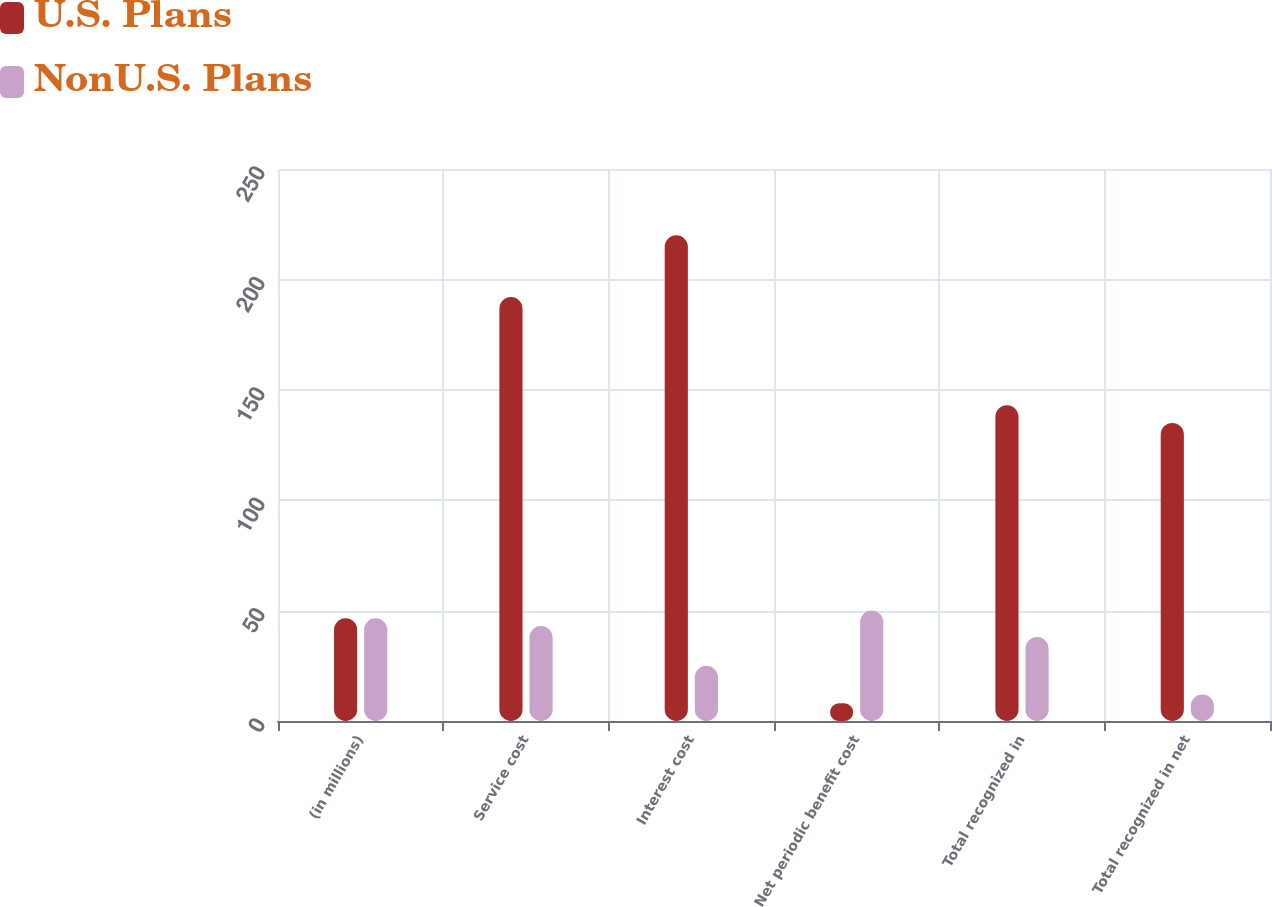Convert chart. <chart><loc_0><loc_0><loc_500><loc_500><stacked_bar_chart><ecel><fcel>(in millions)<fcel>Service cost<fcel>Interest cost<fcel>Net periodic benefit cost<fcel>Total recognized in<fcel>Total recognized in net<nl><fcel>U.S. Plans<fcel>46.5<fcel>192<fcel>220<fcel>8<fcel>143<fcel>135<nl><fcel>NonU.S. Plans<fcel>46.5<fcel>43<fcel>25<fcel>50<fcel>38<fcel>12<nl></chart> 